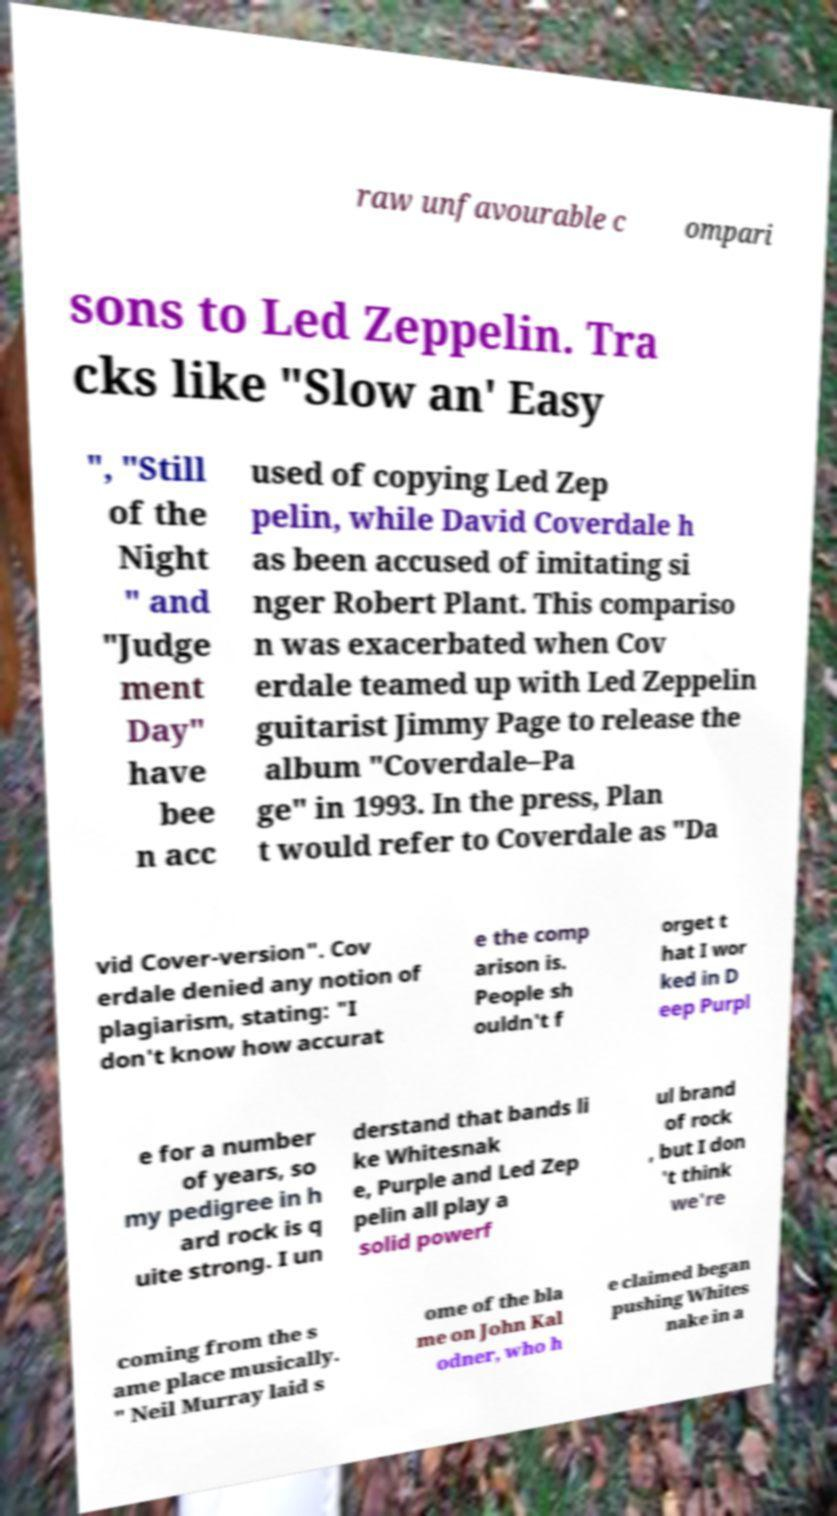What messages or text are displayed in this image? I need them in a readable, typed format. raw unfavourable c ompari sons to Led Zeppelin. Tra cks like "Slow an' Easy ", "Still of the Night " and "Judge ment Day" have bee n acc used of copying Led Zep pelin, while David Coverdale h as been accused of imitating si nger Robert Plant. This compariso n was exacerbated when Cov erdale teamed up with Led Zeppelin guitarist Jimmy Page to release the album "Coverdale–Pa ge" in 1993. In the press, Plan t would refer to Coverdale as "Da vid Cover-version". Cov erdale denied any notion of plagiarism, stating: "I don't know how accurat e the comp arison is. People sh ouldn't f orget t hat I wor ked in D eep Purpl e for a number of years, so my pedigree in h ard rock is q uite strong. I un derstand that bands li ke Whitesnak e, Purple and Led Zep pelin all play a solid powerf ul brand of rock , but I don 't think we're coming from the s ame place musically. " Neil Murray laid s ome of the bla me on John Kal odner, who h e claimed began pushing Whites nake in a 